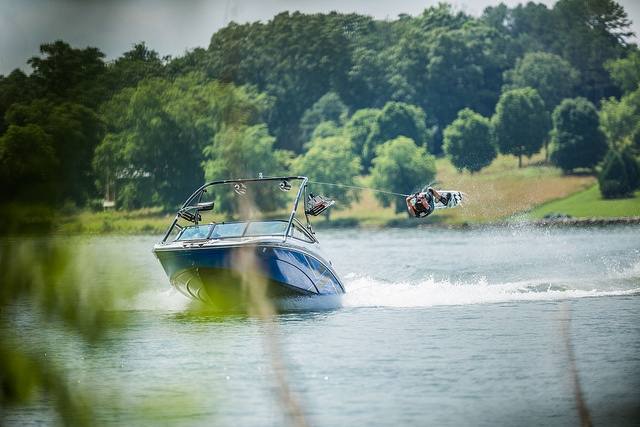Describe the objects in this image and their specific colors. I can see boat in darkgray, gray, olive, and darkgreen tones, people in darkgray, black, gray, and brown tones, and people in darkgray, lightblue, and gray tones in this image. 